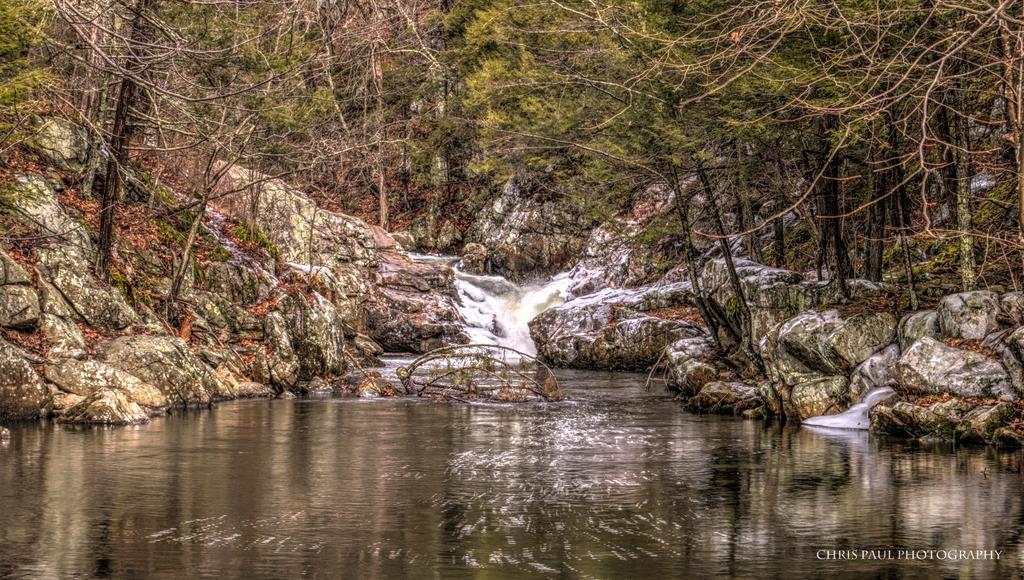Can you describe this image briefly? In this image we can see water. Also there are rocks. And there are trees. In the right bottom corner something is written. 